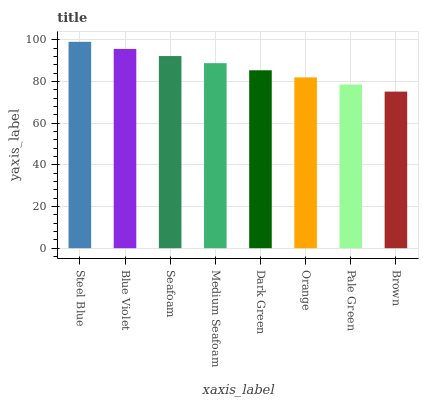Is Brown the minimum?
Answer yes or no. Yes. Is Steel Blue the maximum?
Answer yes or no. Yes. Is Blue Violet the minimum?
Answer yes or no. No. Is Blue Violet the maximum?
Answer yes or no. No. Is Steel Blue greater than Blue Violet?
Answer yes or no. Yes. Is Blue Violet less than Steel Blue?
Answer yes or no. Yes. Is Blue Violet greater than Steel Blue?
Answer yes or no. No. Is Steel Blue less than Blue Violet?
Answer yes or no. No. Is Medium Seafoam the high median?
Answer yes or no. Yes. Is Dark Green the low median?
Answer yes or no. Yes. Is Brown the high median?
Answer yes or no. No. Is Orange the low median?
Answer yes or no. No. 